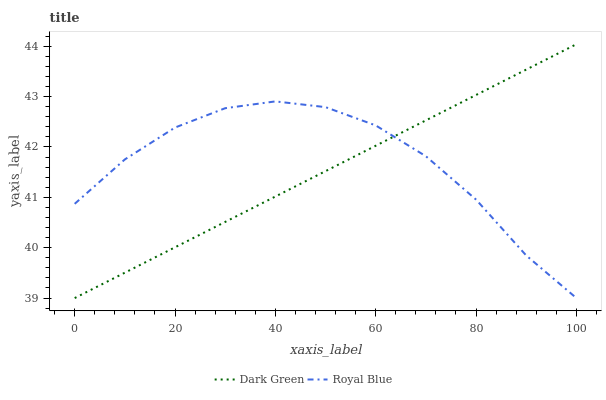Does Dark Green have the minimum area under the curve?
Answer yes or no. Yes. Does Royal Blue have the maximum area under the curve?
Answer yes or no. Yes. Does Dark Green have the maximum area under the curve?
Answer yes or no. No. Is Dark Green the smoothest?
Answer yes or no. Yes. Is Royal Blue the roughest?
Answer yes or no. Yes. Is Dark Green the roughest?
Answer yes or no. No. Does Royal Blue have the lowest value?
Answer yes or no. Yes. Does Dark Green have the highest value?
Answer yes or no. Yes. Does Dark Green intersect Royal Blue?
Answer yes or no. Yes. Is Dark Green less than Royal Blue?
Answer yes or no. No. Is Dark Green greater than Royal Blue?
Answer yes or no. No. 